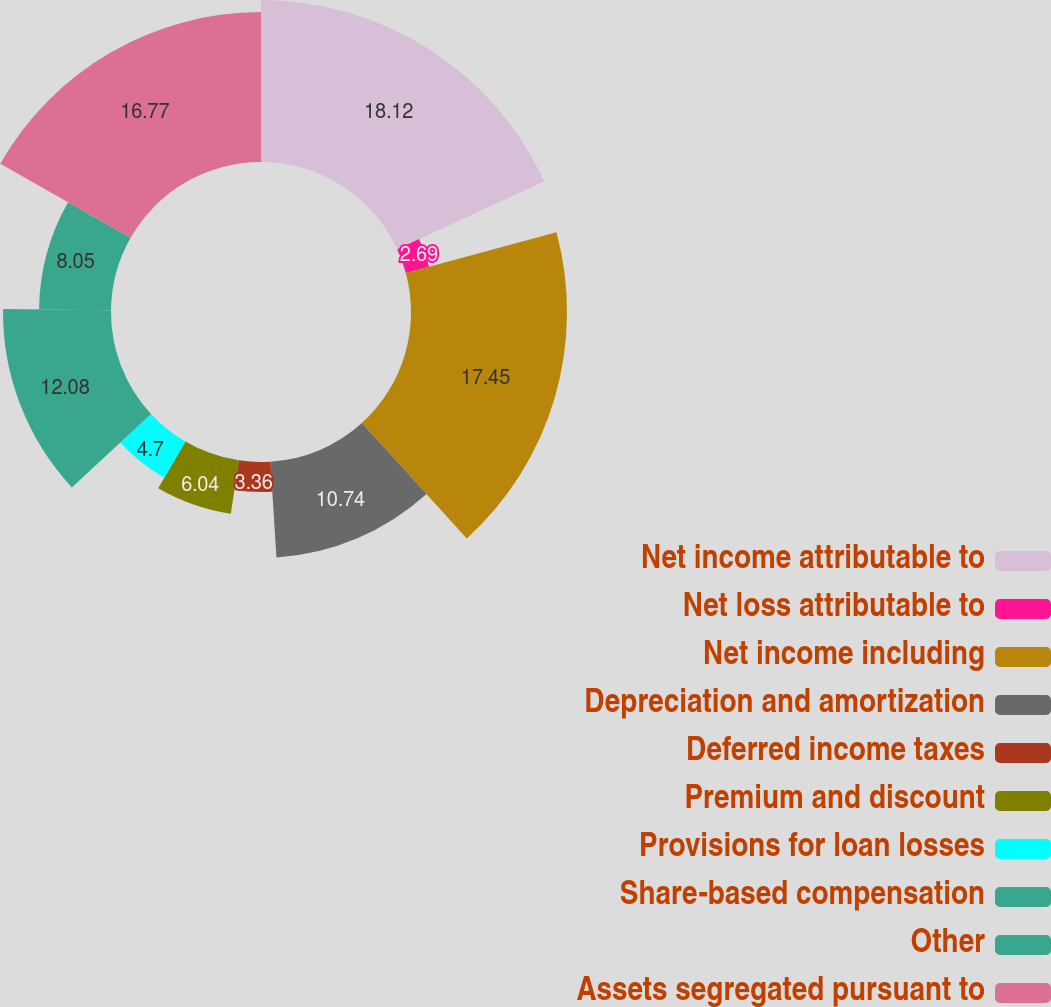<chart> <loc_0><loc_0><loc_500><loc_500><pie_chart><fcel>Net income attributable to<fcel>Net loss attributable to<fcel>Net income including<fcel>Depreciation and amortization<fcel>Deferred income taxes<fcel>Premium and discount<fcel>Provisions for loan losses<fcel>Share-based compensation<fcel>Other<fcel>Assets segregated pursuant to<nl><fcel>18.12%<fcel>2.69%<fcel>17.45%<fcel>10.74%<fcel>3.36%<fcel>6.04%<fcel>4.7%<fcel>12.08%<fcel>8.05%<fcel>16.77%<nl></chart> 